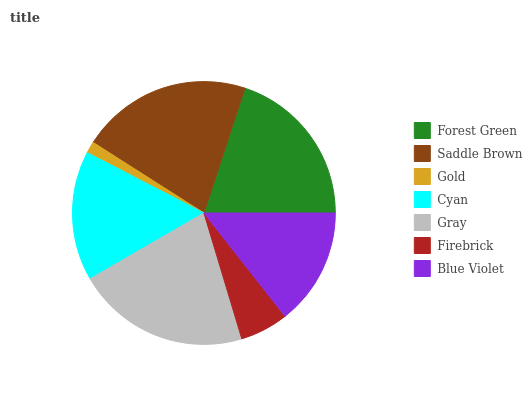Is Gold the minimum?
Answer yes or no. Yes. Is Gray the maximum?
Answer yes or no. Yes. Is Saddle Brown the minimum?
Answer yes or no. No. Is Saddle Brown the maximum?
Answer yes or no. No. Is Saddle Brown greater than Forest Green?
Answer yes or no. Yes. Is Forest Green less than Saddle Brown?
Answer yes or no. Yes. Is Forest Green greater than Saddle Brown?
Answer yes or no. No. Is Saddle Brown less than Forest Green?
Answer yes or no. No. Is Cyan the high median?
Answer yes or no. Yes. Is Cyan the low median?
Answer yes or no. Yes. Is Blue Violet the high median?
Answer yes or no. No. Is Forest Green the low median?
Answer yes or no. No. 